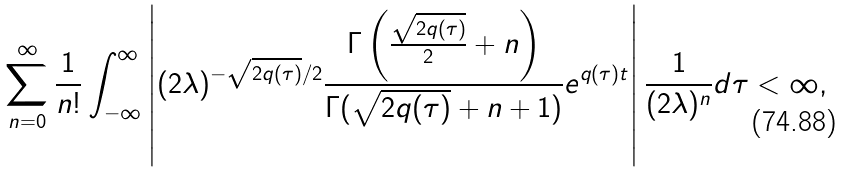Convert formula to latex. <formula><loc_0><loc_0><loc_500><loc_500>\sum _ { n = 0 } ^ { \infty } \frac { 1 } { n ! } \int _ { - \infty } ^ { \infty } \left | ( 2 \lambda ) ^ { - \sqrt { 2 q ( \tau ) } / 2 } \frac { \Gamma \left ( \frac { \sqrt { 2 q ( \tau ) } } { 2 } + n \right ) } { \Gamma ( \sqrt { 2 q ( \tau ) } + n + 1 ) } e ^ { q ( \tau ) t } \right | \frac { 1 } { ( 2 \lambda ) ^ { n } } d \tau < \infty ,</formula> 